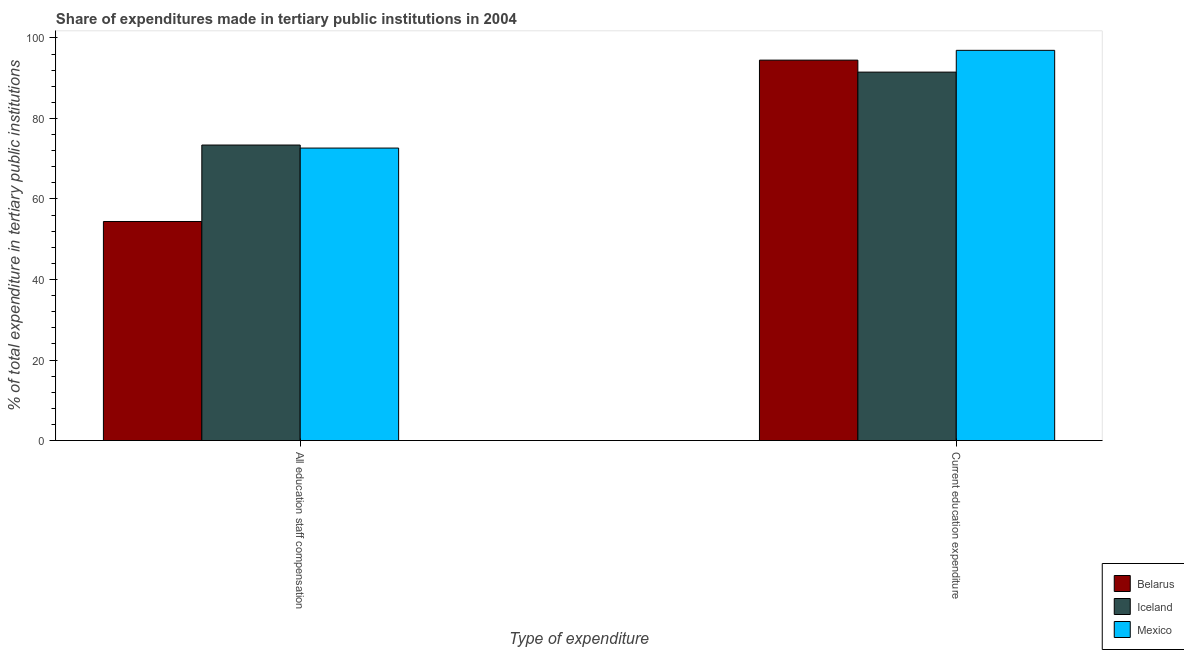How many groups of bars are there?
Provide a short and direct response. 2. How many bars are there on the 1st tick from the right?
Your response must be concise. 3. What is the label of the 1st group of bars from the left?
Provide a succinct answer. All education staff compensation. What is the expenditure in education in Iceland?
Offer a terse response. 91.51. Across all countries, what is the maximum expenditure in education?
Provide a succinct answer. 96.92. Across all countries, what is the minimum expenditure in staff compensation?
Make the answer very short. 54.41. In which country was the expenditure in education maximum?
Offer a very short reply. Mexico. In which country was the expenditure in education minimum?
Your answer should be very brief. Iceland. What is the total expenditure in staff compensation in the graph?
Provide a succinct answer. 200.46. What is the difference between the expenditure in staff compensation in Mexico and that in Belarus?
Give a very brief answer. 18.23. What is the difference between the expenditure in education in Iceland and the expenditure in staff compensation in Belarus?
Ensure brevity in your answer.  37.1. What is the average expenditure in education per country?
Give a very brief answer. 94.3. What is the difference between the expenditure in education and expenditure in staff compensation in Mexico?
Your answer should be compact. 24.27. What is the ratio of the expenditure in education in Iceland to that in Mexico?
Ensure brevity in your answer.  0.94. Is the expenditure in staff compensation in Iceland less than that in Mexico?
Your answer should be compact. No. In how many countries, is the expenditure in education greater than the average expenditure in education taken over all countries?
Make the answer very short. 2. What does the 3rd bar from the left in Current education expenditure represents?
Provide a succinct answer. Mexico. What does the 3rd bar from the right in All education staff compensation represents?
Keep it short and to the point. Belarus. How many bars are there?
Offer a terse response. 6. Are all the bars in the graph horizontal?
Ensure brevity in your answer.  No. How many countries are there in the graph?
Provide a short and direct response. 3. Are the values on the major ticks of Y-axis written in scientific E-notation?
Offer a very short reply. No. Does the graph contain any zero values?
Offer a very short reply. No. Does the graph contain grids?
Your response must be concise. No. Where does the legend appear in the graph?
Keep it short and to the point. Bottom right. How are the legend labels stacked?
Make the answer very short. Vertical. What is the title of the graph?
Ensure brevity in your answer.  Share of expenditures made in tertiary public institutions in 2004. Does "Syrian Arab Republic" appear as one of the legend labels in the graph?
Make the answer very short. No. What is the label or title of the X-axis?
Ensure brevity in your answer.  Type of expenditure. What is the label or title of the Y-axis?
Your answer should be very brief. % of total expenditure in tertiary public institutions. What is the % of total expenditure in tertiary public institutions of Belarus in All education staff compensation?
Make the answer very short. 54.41. What is the % of total expenditure in tertiary public institutions in Iceland in All education staff compensation?
Make the answer very short. 73.4. What is the % of total expenditure in tertiary public institutions in Mexico in All education staff compensation?
Ensure brevity in your answer.  72.65. What is the % of total expenditure in tertiary public institutions in Belarus in Current education expenditure?
Your answer should be very brief. 94.49. What is the % of total expenditure in tertiary public institutions in Iceland in Current education expenditure?
Give a very brief answer. 91.51. What is the % of total expenditure in tertiary public institutions in Mexico in Current education expenditure?
Offer a very short reply. 96.92. Across all Type of expenditure, what is the maximum % of total expenditure in tertiary public institutions in Belarus?
Make the answer very short. 94.49. Across all Type of expenditure, what is the maximum % of total expenditure in tertiary public institutions in Iceland?
Make the answer very short. 91.51. Across all Type of expenditure, what is the maximum % of total expenditure in tertiary public institutions of Mexico?
Offer a very short reply. 96.92. Across all Type of expenditure, what is the minimum % of total expenditure in tertiary public institutions in Belarus?
Your answer should be compact. 54.41. Across all Type of expenditure, what is the minimum % of total expenditure in tertiary public institutions in Iceland?
Provide a short and direct response. 73.4. Across all Type of expenditure, what is the minimum % of total expenditure in tertiary public institutions of Mexico?
Make the answer very short. 72.65. What is the total % of total expenditure in tertiary public institutions of Belarus in the graph?
Offer a very short reply. 148.9. What is the total % of total expenditure in tertiary public institutions in Iceland in the graph?
Provide a short and direct response. 164.91. What is the total % of total expenditure in tertiary public institutions of Mexico in the graph?
Your response must be concise. 169.56. What is the difference between the % of total expenditure in tertiary public institutions of Belarus in All education staff compensation and that in Current education expenditure?
Offer a very short reply. -40.07. What is the difference between the % of total expenditure in tertiary public institutions of Iceland in All education staff compensation and that in Current education expenditure?
Offer a very short reply. -18.11. What is the difference between the % of total expenditure in tertiary public institutions of Mexico in All education staff compensation and that in Current education expenditure?
Keep it short and to the point. -24.27. What is the difference between the % of total expenditure in tertiary public institutions of Belarus in All education staff compensation and the % of total expenditure in tertiary public institutions of Iceland in Current education expenditure?
Provide a succinct answer. -37.1. What is the difference between the % of total expenditure in tertiary public institutions in Belarus in All education staff compensation and the % of total expenditure in tertiary public institutions in Mexico in Current education expenditure?
Ensure brevity in your answer.  -42.51. What is the difference between the % of total expenditure in tertiary public institutions in Iceland in All education staff compensation and the % of total expenditure in tertiary public institutions in Mexico in Current education expenditure?
Offer a very short reply. -23.52. What is the average % of total expenditure in tertiary public institutions in Belarus per Type of expenditure?
Make the answer very short. 74.45. What is the average % of total expenditure in tertiary public institutions of Iceland per Type of expenditure?
Your answer should be compact. 82.45. What is the average % of total expenditure in tertiary public institutions in Mexico per Type of expenditure?
Your answer should be very brief. 84.78. What is the difference between the % of total expenditure in tertiary public institutions in Belarus and % of total expenditure in tertiary public institutions in Iceland in All education staff compensation?
Your answer should be very brief. -18.99. What is the difference between the % of total expenditure in tertiary public institutions of Belarus and % of total expenditure in tertiary public institutions of Mexico in All education staff compensation?
Give a very brief answer. -18.23. What is the difference between the % of total expenditure in tertiary public institutions in Iceland and % of total expenditure in tertiary public institutions in Mexico in All education staff compensation?
Your answer should be very brief. 0.75. What is the difference between the % of total expenditure in tertiary public institutions of Belarus and % of total expenditure in tertiary public institutions of Iceland in Current education expenditure?
Keep it short and to the point. 2.98. What is the difference between the % of total expenditure in tertiary public institutions of Belarus and % of total expenditure in tertiary public institutions of Mexico in Current education expenditure?
Ensure brevity in your answer.  -2.43. What is the difference between the % of total expenditure in tertiary public institutions of Iceland and % of total expenditure in tertiary public institutions of Mexico in Current education expenditure?
Keep it short and to the point. -5.41. What is the ratio of the % of total expenditure in tertiary public institutions of Belarus in All education staff compensation to that in Current education expenditure?
Provide a succinct answer. 0.58. What is the ratio of the % of total expenditure in tertiary public institutions in Iceland in All education staff compensation to that in Current education expenditure?
Your response must be concise. 0.8. What is the ratio of the % of total expenditure in tertiary public institutions in Mexico in All education staff compensation to that in Current education expenditure?
Provide a short and direct response. 0.75. What is the difference between the highest and the second highest % of total expenditure in tertiary public institutions of Belarus?
Ensure brevity in your answer.  40.07. What is the difference between the highest and the second highest % of total expenditure in tertiary public institutions of Iceland?
Provide a succinct answer. 18.11. What is the difference between the highest and the second highest % of total expenditure in tertiary public institutions of Mexico?
Give a very brief answer. 24.27. What is the difference between the highest and the lowest % of total expenditure in tertiary public institutions of Belarus?
Offer a very short reply. 40.07. What is the difference between the highest and the lowest % of total expenditure in tertiary public institutions in Iceland?
Provide a short and direct response. 18.11. What is the difference between the highest and the lowest % of total expenditure in tertiary public institutions of Mexico?
Offer a very short reply. 24.27. 